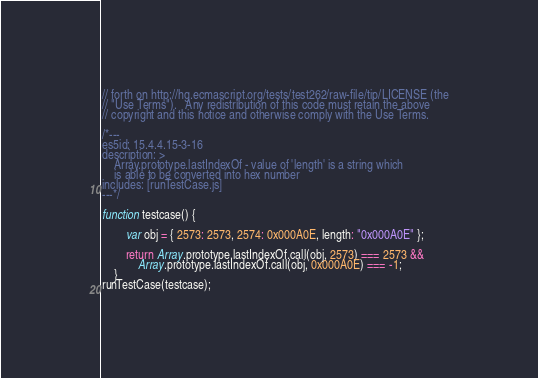Convert code to text. <code><loc_0><loc_0><loc_500><loc_500><_JavaScript_>// forth on http://hg.ecmascript.org/tests/test262/raw-file/tip/LICENSE (the
// "Use Terms").   Any redistribution of this code must retain the above
// copyright and this notice and otherwise comply with the Use Terms.

/*---
es5id: 15.4.4.15-3-16
description: >
    Array.prototype.lastIndexOf - value of 'length' is a string which
    is able to be converted into hex number
includes: [runTestCase.js]
---*/

function testcase() {

        var obj = { 2573: 2573, 2574: 0x000A0E, length: "0x000A0E" };

        return Array.prototype.lastIndexOf.call(obj, 2573) === 2573 &&
            Array.prototype.lastIndexOf.call(obj, 0x000A0E) === -1;
    }
runTestCase(testcase);
</code> 